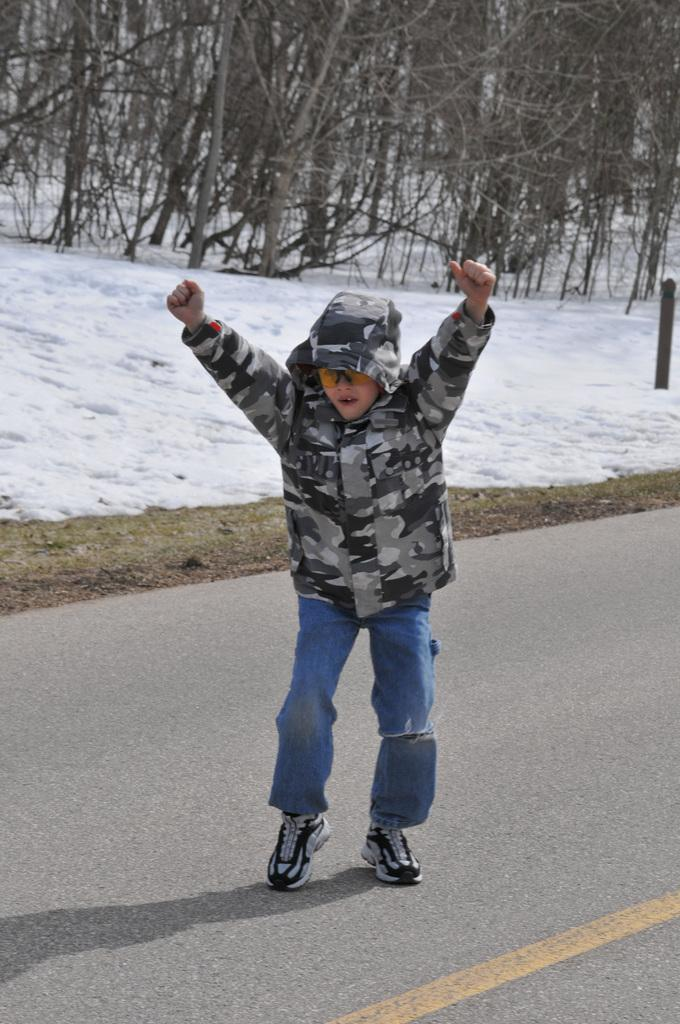Who or what is the main subject in the image? There is a kid in the image. Where is the kid located? The kid is on the road. What is the weather like in the image? There is snow in the image, indicating a cold and likely wintery scene. What can be seen in the background of the image? There are trees at the top of the image. What type of summer activity is the kid participating in the image? The image does not depict a summer activity, as there is snow present, indicating a cold and likely wintery scene. 